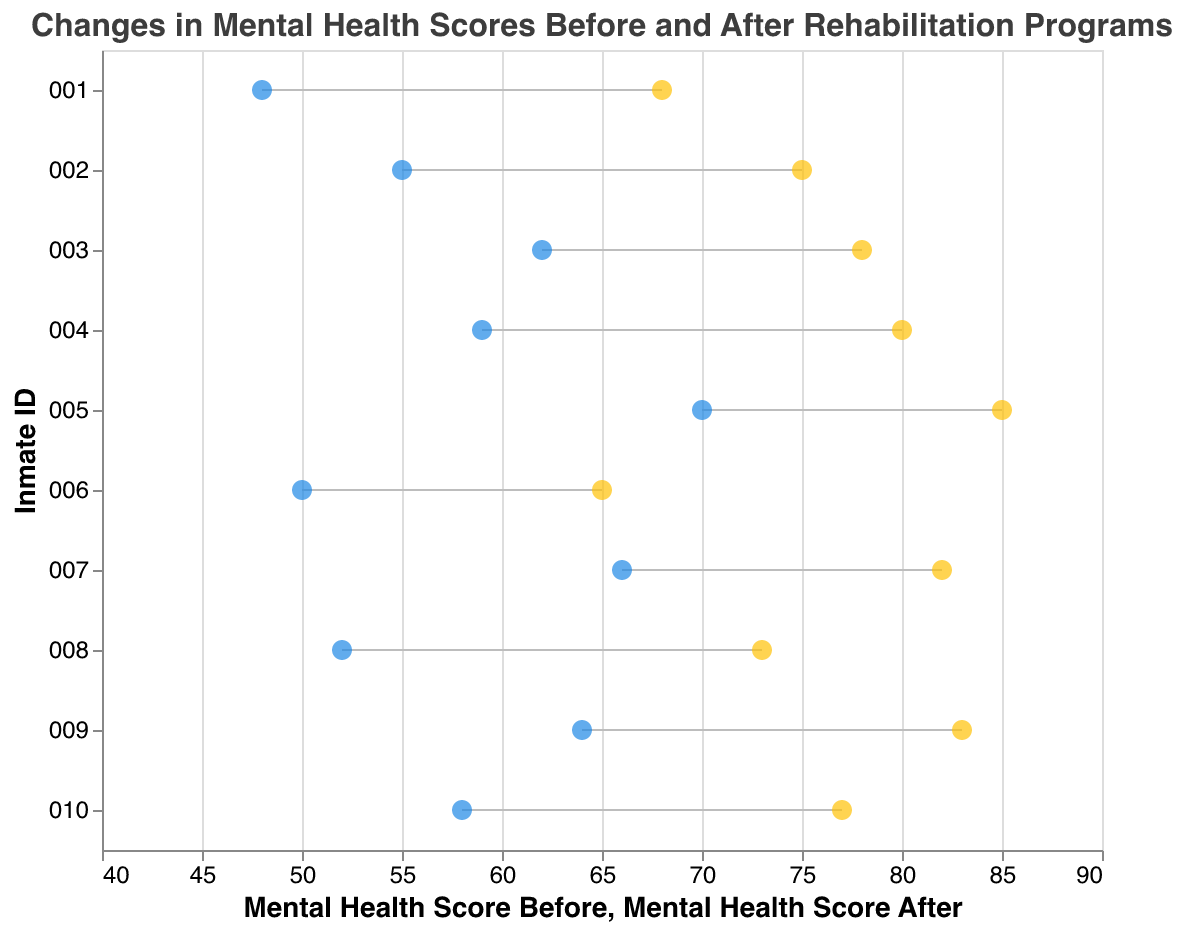What is the title of the plot? The title is usually positioned at the top of the plot, readable in the largest font on the figure.
Answer: Changes in Mental Health Scores Before and After Rehabilitation Programs How many inmates are shown in the plot? Count the number of unique "Inmate ID" labels along the y-axis.
Answer: 10 Which inmate had the highest increase in their mental health score after the rehabilitation program? Look for the largest vertical distance between the two point marks for each inmate. Inmate 004 moved from 59 to 80, a difference of 21.
Answer: Inmate 004 What program type shows the largest improvement in mental health scores overall? Group the inmates by "Program Type" and compare the range of the changes in scores. Mindfulness Training has significant improvements among inmates 002, 005, and 009.
Answer: Mindfulness Training What is the average mental health score before the rehabilitation program for the inmates? Sum all the initial scores and divide by the total number of inmates: (48 + 55 + 62 + 59 + 70 + 50 + 66 + 52 + 64 + 58) / 10.
Answer: 58.4 Who had the smallest change in their mental health score after the program? Identify the inmate with the smallest vertical distance between the two point marks for "Before" and "After" scores. Inmate 006 had a change from 50 to 65, which is 15.
Answer: Inmate 006 Between the inmates who participated in "CBT" programs, who had the highest score after the program? Among Inmates 001, 006, and 010, compare their post-program scores: 68, 65, and 77.
Answer: Inmate 010 Which gender showed greater overall improvement in mental health scores? Calculate the sum of differences between "Before" and "After" scores grouped by gender and compare them. Females overall improved more (20 + 16 + 16 + 19 = 71) compared to males (20 + 21 + 21 + 15 = 77).
Answer: Male What is the median mental health score after the program for all inmates? List the post-program scores in ascending order: 65, 68, 73, 75, 77, 78, 80, 82, 83, 85, and find the middle value.
Answer: 77.5 